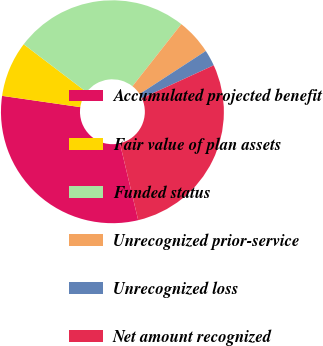<chart> <loc_0><loc_0><loc_500><loc_500><pie_chart><fcel>Accumulated projected benefit<fcel>Fair value of plan assets<fcel>Funded status<fcel>Unrecognized prior-service<fcel>Unrecognized loss<fcel>Net amount recognized<nl><fcel>30.99%<fcel>8.07%<fcel>25.26%<fcel>5.21%<fcel>2.34%<fcel>28.12%<nl></chart> 